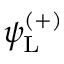Convert formula to latex. <formula><loc_0><loc_0><loc_500><loc_500>\psi _ { L } ^ { ( + ) }</formula> 